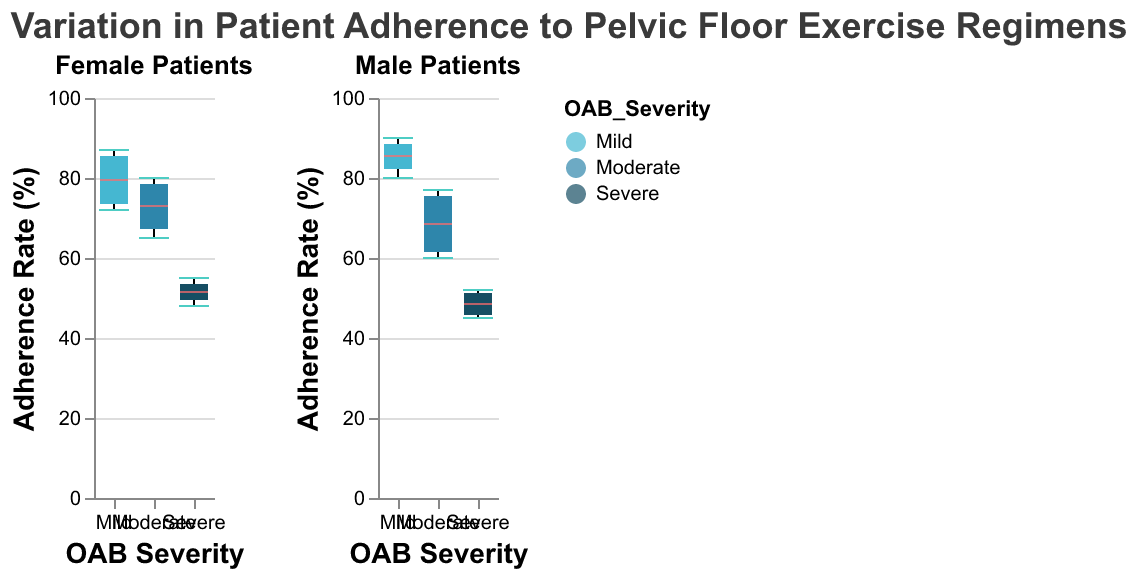What is the title of the figure? The title of the figure is usually placed at the top and can be read directly from the plot.
Answer: Variation in Patient Adherence to Pelvic Floor Exercise Regimens What is the maximum adherence rate for male patients with mild OAB severity? Look at the box plot for male patients with mild OAB severity and identify the maximum whisker/tick value.
Answer: 90 Which gender has a higher median adherence rate for severe OAB severity? Compare the median lines in the box plots for severe OAB severity for both male and female patients.
Answer: Female What is the range of adherence rates for female patients with moderate OAB severity? Look at the box plot for female patients with moderate OAB severity and identify the minimum and maximum whisker/tick values.
Answer: 65-80 Which OAB severity group shows the greatest variation in adherence rates for male patients? Compare the length of the box (interquartile range) and the whiskers (overall range) in the box plots for male patients across different OAB severity groups.
Answer: Mild How does the median adherence rate for male patients with moderate OAB severity compare to that for female patients with the same severity? Compare the positions of the median lines in the box plots for male and female patients with moderate OAB severity.
Answer: Lower What is the interquartile range (IQR) for adherence rates in female patients with mild OAB severity? Identify the values at the lower quartile (Q1) and the upper quartile (Q3) on the box plot, then calculate the difference (Q3 - Q1).
Answer: 74-85 Are there any outliers in adherence rates for male patients with severe OAB severity? Look for any points outside the whiskers in the box plot for male patients with severe OAB severity.
Answer: No Which OAB severity group has the smallest median adherence rate for female patients? Compare the median lines in the box plots for female patients across different OAB severity groups.
Answer: Severe 